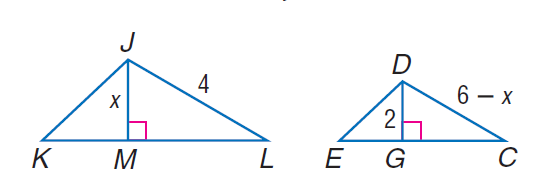Answer the mathemtical geometry problem and directly provide the correct option letter.
Question: Find D C if D G and J M are altitudes and \triangle K J L \sim \triangle E D C.
Choices: A: 2 B: 4 C: 6 D: 8 B 